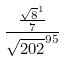<formula> <loc_0><loc_0><loc_500><loc_500>\frac { \frac { \sqrt { 8 } ^ { 1 } } { 7 } } { \sqrt { 2 0 2 } ^ { 9 5 } }</formula> 